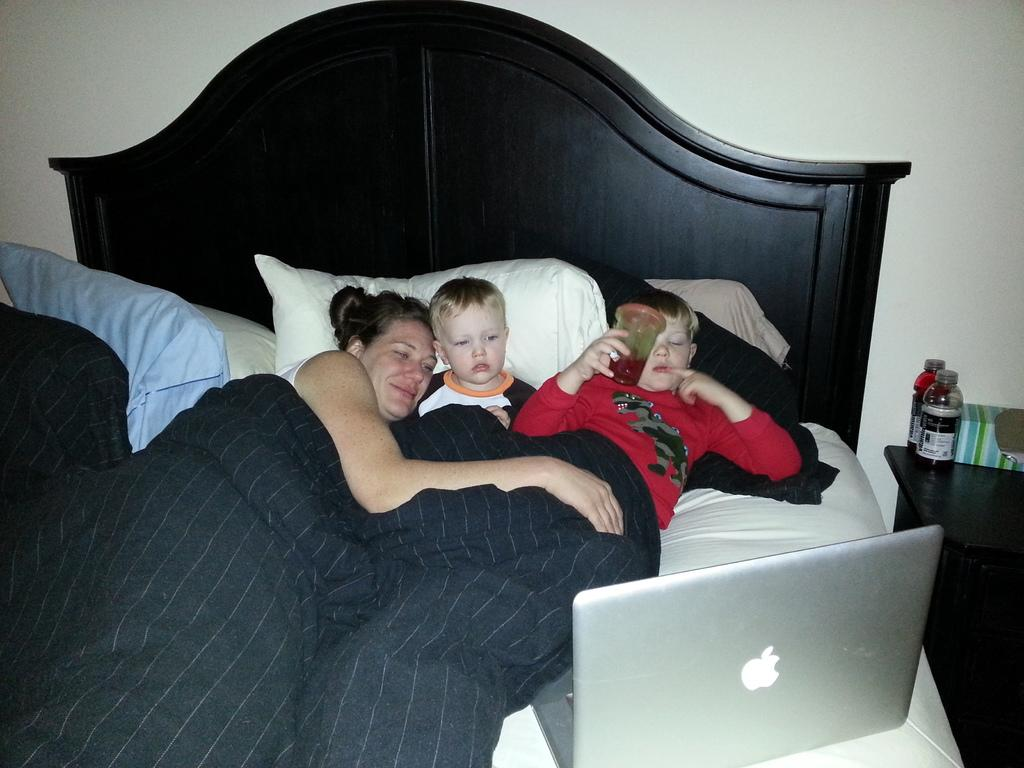How many people are in the image? There are three individuals in the image, two boys and a woman. What are the people in the image doing? All three individuals are lying on a bed. What is in front of the people in the image? There is a system (possibly an electronic device) in front of them. Can you see any objects related to hydration in the image? Yes, there are bottles visible in the image. What type of crime is being committed in the image? There is no indication of a crime being committed in the image. The individuals are simply lying on a bed with a system in front of them and bottles nearby. 